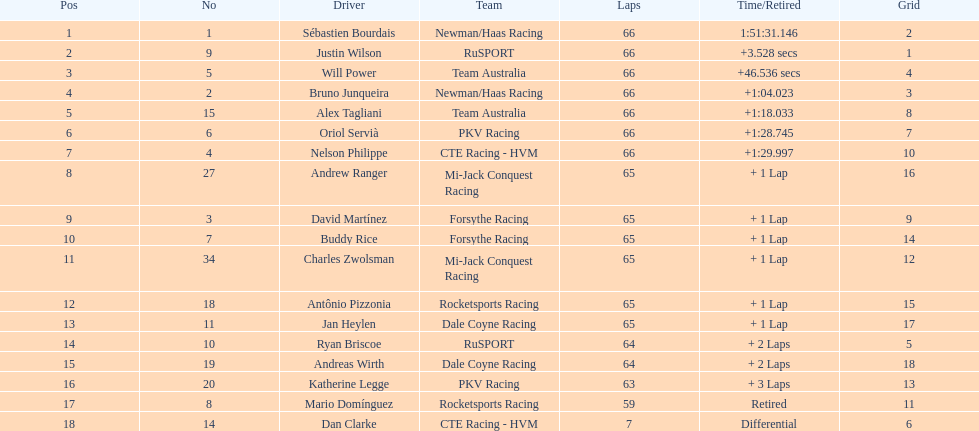Which country had more drivers representing them, the us or germany? Tie. 